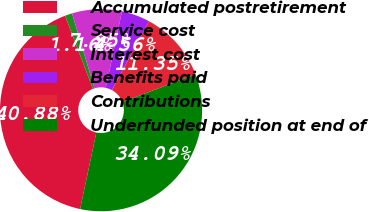Convert chart to OTSL. <chart><loc_0><loc_0><loc_500><loc_500><pie_chart><fcel>Accumulated postretirement<fcel>Service cost<fcel>Interest cost<fcel>Benefits paid<fcel>Contributions<fcel>Underfunded position at end of<nl><fcel>40.88%<fcel>1.16%<fcel>7.95%<fcel>4.56%<fcel>11.35%<fcel>34.09%<nl></chart> 